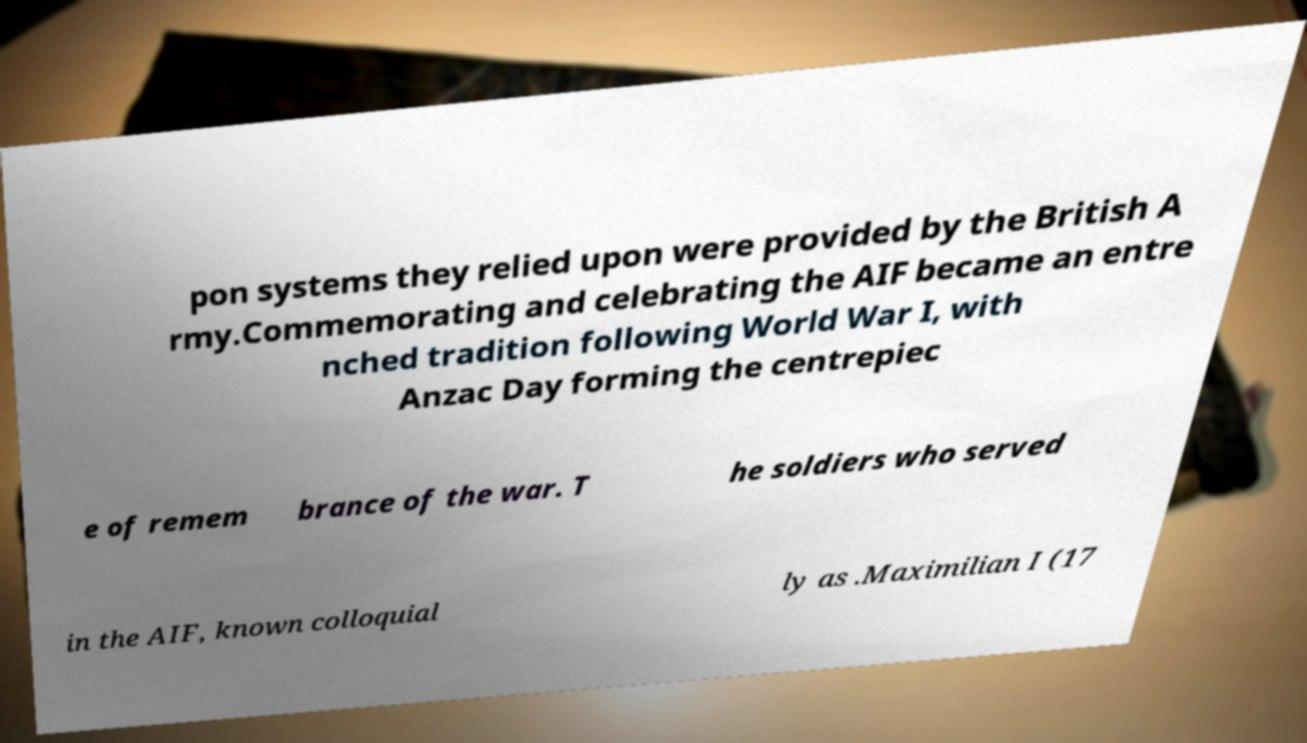There's text embedded in this image that I need extracted. Can you transcribe it verbatim? pon systems they relied upon were provided by the British A rmy.Commemorating and celebrating the AIF became an entre nched tradition following World War I, with Anzac Day forming the centrepiec e of remem brance of the war. T he soldiers who served in the AIF, known colloquial ly as .Maximilian I (17 